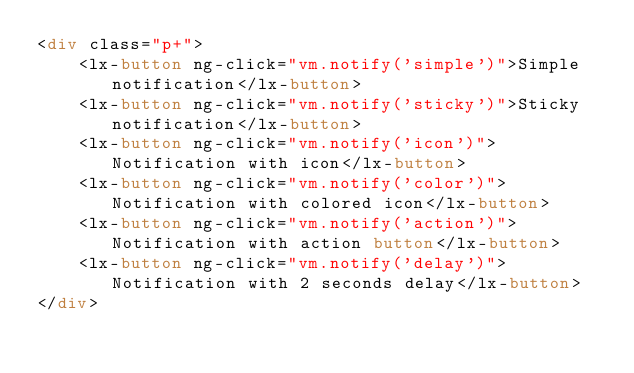<code> <loc_0><loc_0><loc_500><loc_500><_HTML_><div class="p+">
    <lx-button ng-click="vm.notify('simple')">Simple notification</lx-button>
    <lx-button ng-click="vm.notify('sticky')">Sticky notification</lx-button>
    <lx-button ng-click="vm.notify('icon')">Notification with icon</lx-button>
    <lx-button ng-click="vm.notify('color')">Notification with colored icon</lx-button>
    <lx-button ng-click="vm.notify('action')">Notification with action button</lx-button>
    <lx-button ng-click="vm.notify('delay')">Notification with 2 seconds delay</lx-button>
</div></code> 